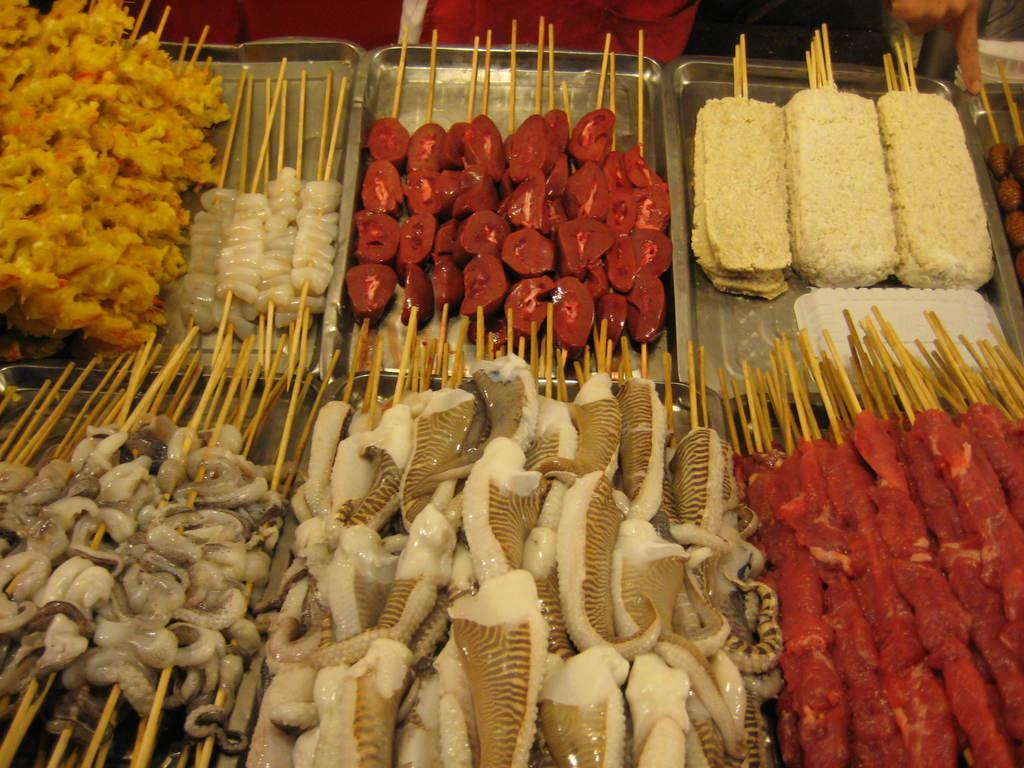What type of food is on sticks in the image? There are non-veg pieces on sticks in the image. How are the non-veg pieces arranged? The non-veg pieces are arranged in a stainless plate. Can you see a tiger cub playing with a boat in the image? No, there is no boat, tiger, or cub present in the image. 